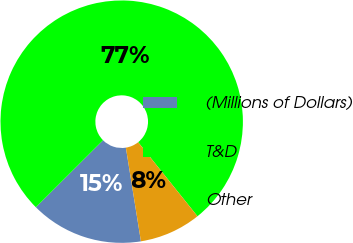Convert chart to OTSL. <chart><loc_0><loc_0><loc_500><loc_500><pie_chart><fcel>(Millions of Dollars)<fcel>T&D<fcel>Other<nl><fcel>15.06%<fcel>76.72%<fcel>8.21%<nl></chart> 